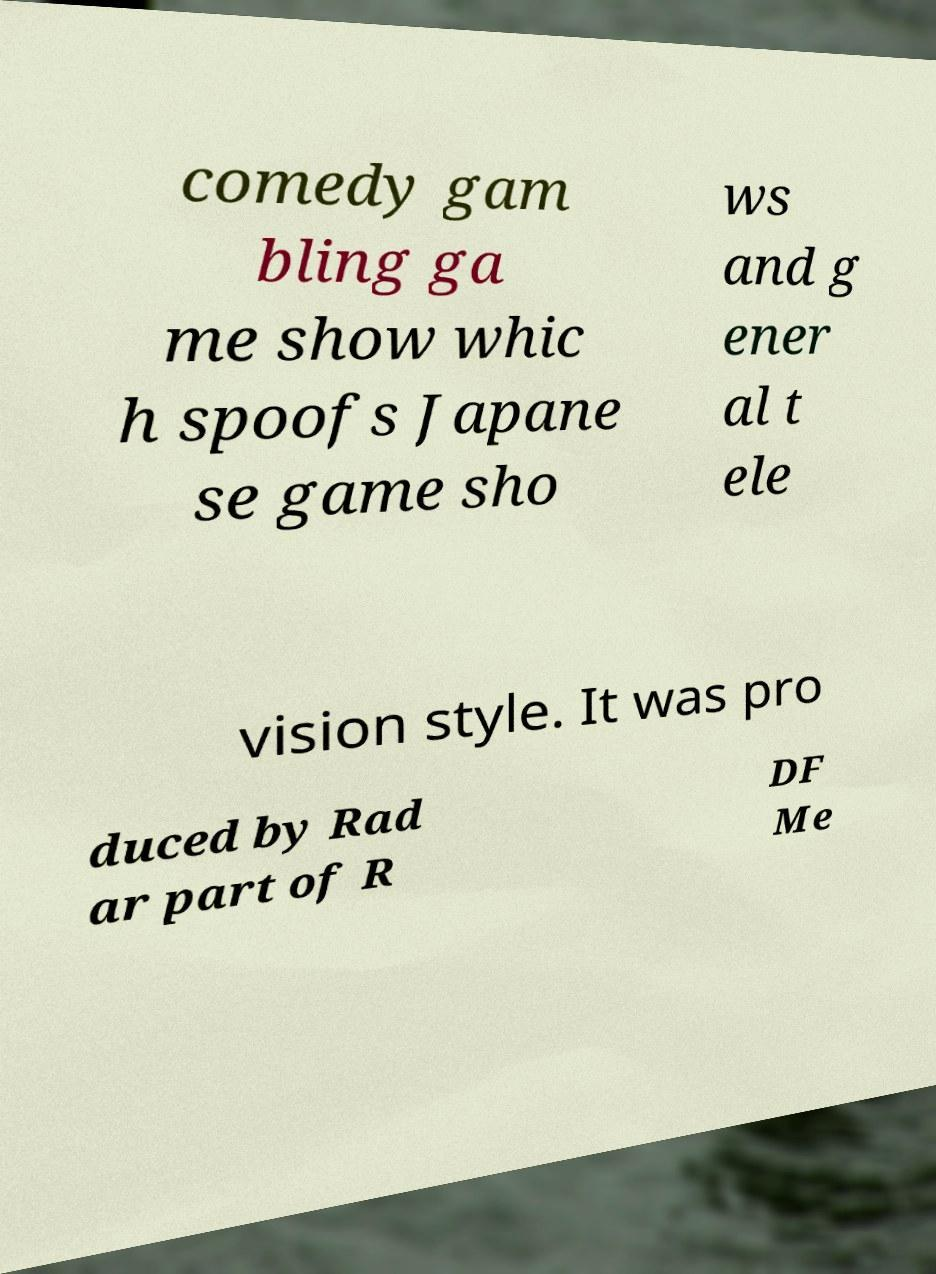Please read and relay the text visible in this image. What does it say? comedy gam bling ga me show whic h spoofs Japane se game sho ws and g ener al t ele vision style. It was pro duced by Rad ar part of R DF Me 